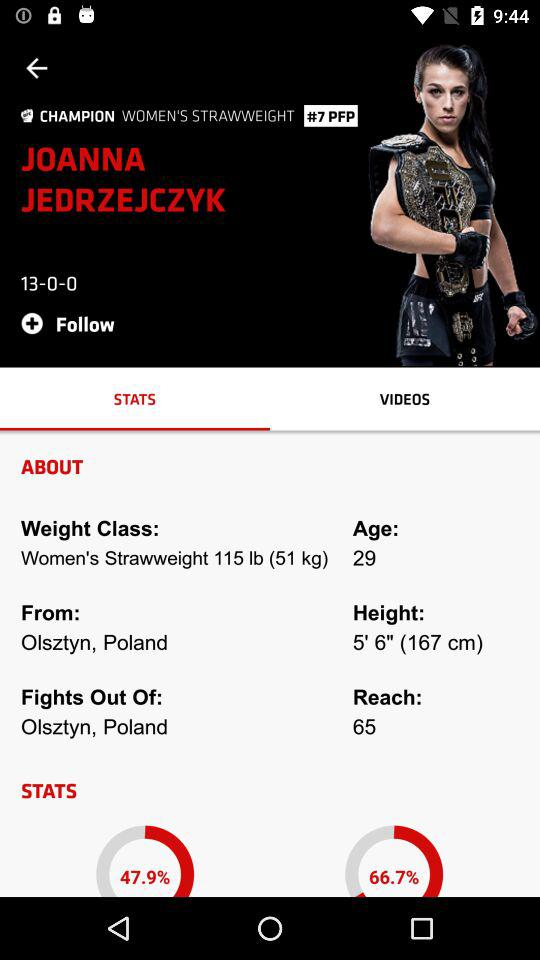What is the age of Joanna Jedrzejczyk? The age is 29 years. 